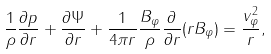<formula> <loc_0><loc_0><loc_500><loc_500>\frac { 1 } { \rho } \frac { \partial p } { \partial r } + \frac { \partial \Psi } { \partial r } + \frac { 1 } { 4 \pi r } \frac { B _ { \varphi } } { \rho } \frac { \partial } { \partial r } ( r B _ { \varphi } ) = \frac { v _ { \varphi } ^ { 2 } } { r } ,</formula> 